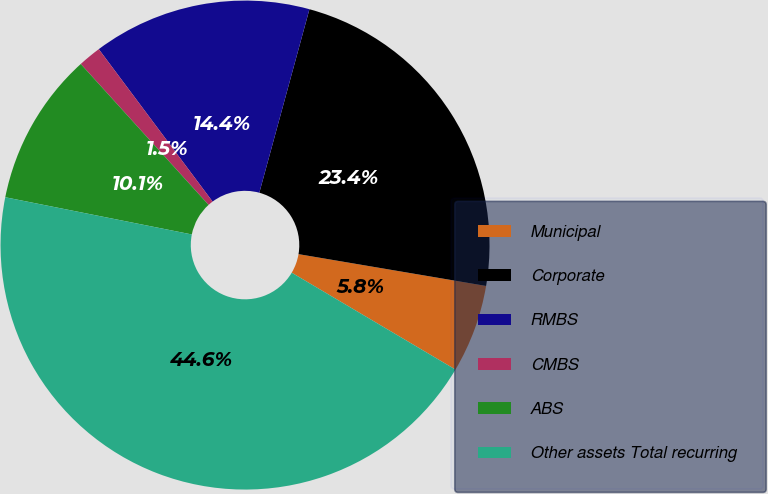<chart> <loc_0><loc_0><loc_500><loc_500><pie_chart><fcel>Municipal<fcel>Corporate<fcel>RMBS<fcel>CMBS<fcel>ABS<fcel>Other assets Total recurring<nl><fcel>5.83%<fcel>23.43%<fcel>14.45%<fcel>1.52%<fcel>10.14%<fcel>44.63%<nl></chart> 